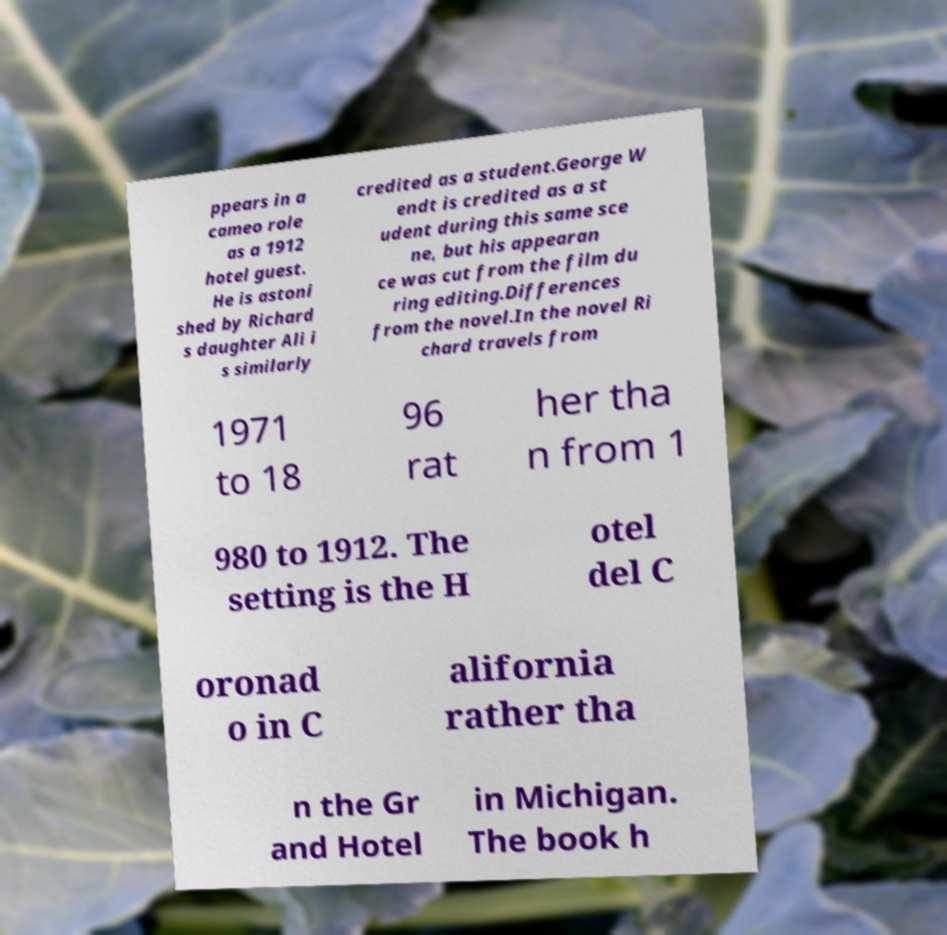For documentation purposes, I need the text within this image transcribed. Could you provide that? ppears in a cameo role as a 1912 hotel guest. He is astoni shed by Richard s daughter Ali i s similarly credited as a student.George W endt is credited as a st udent during this same sce ne, but his appearan ce was cut from the film du ring editing.Differences from the novel.In the novel Ri chard travels from 1971 to 18 96 rat her tha n from 1 980 to 1912. The setting is the H otel del C oronad o in C alifornia rather tha n the Gr and Hotel in Michigan. The book h 